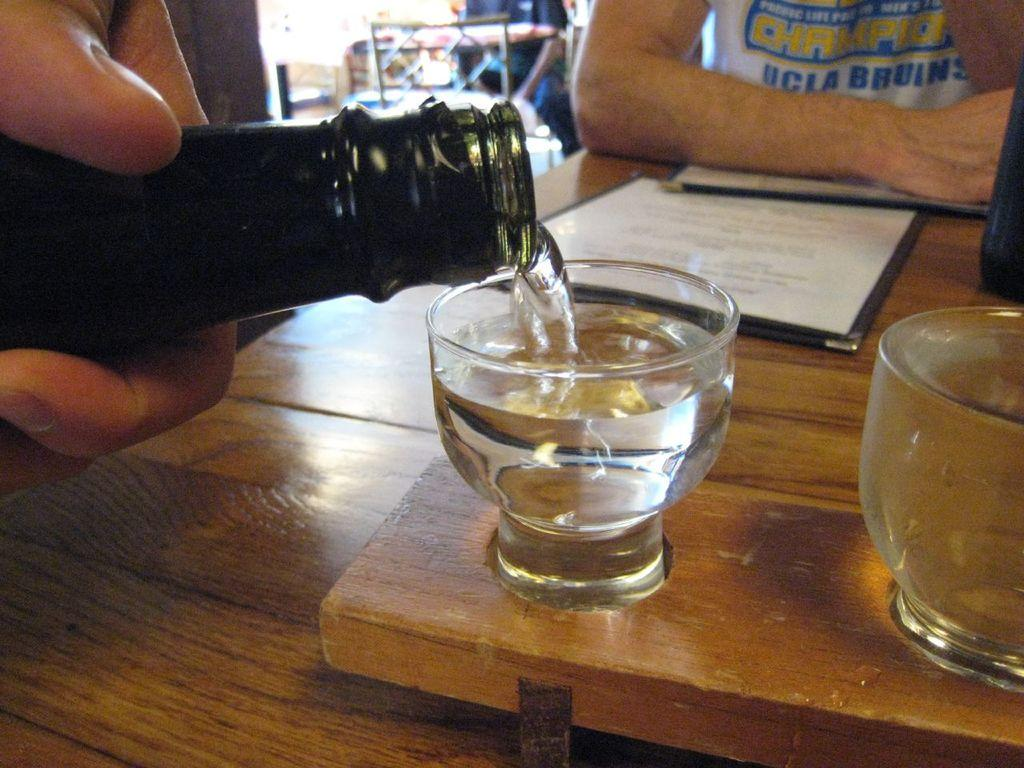<image>
Offer a succinct explanation of the picture presented. Champions UCLA Bruins shirt that a man is wearing along with a wine bottle being poured into a small cup. 